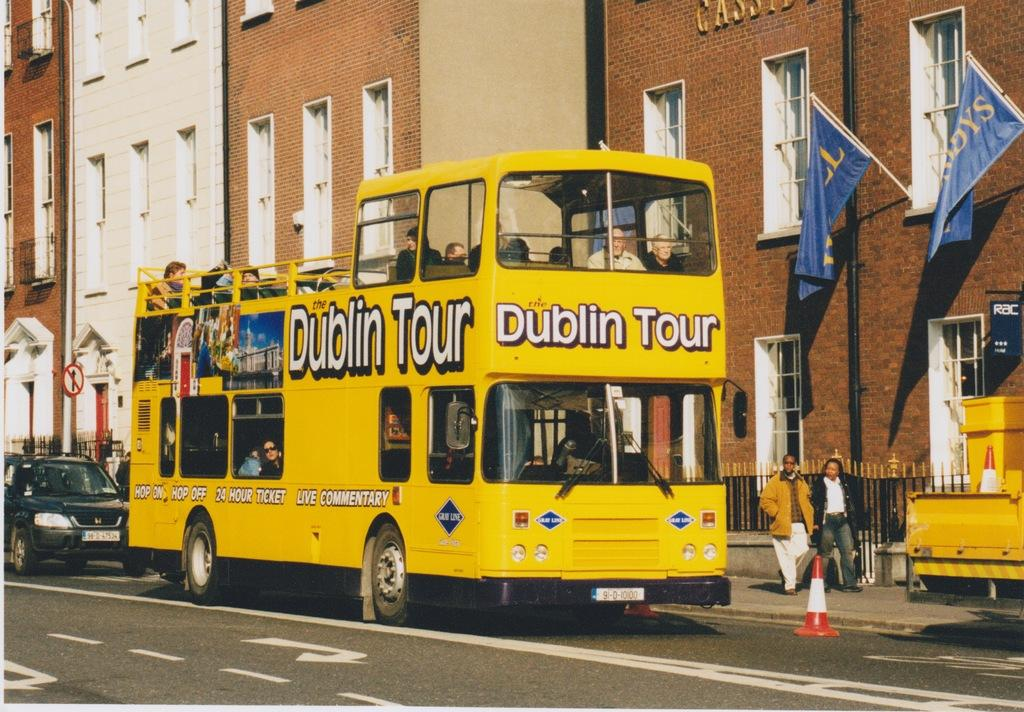<image>
Provide a brief description of the given image. A yellow Dublin Tour double decker bus in traffic. 